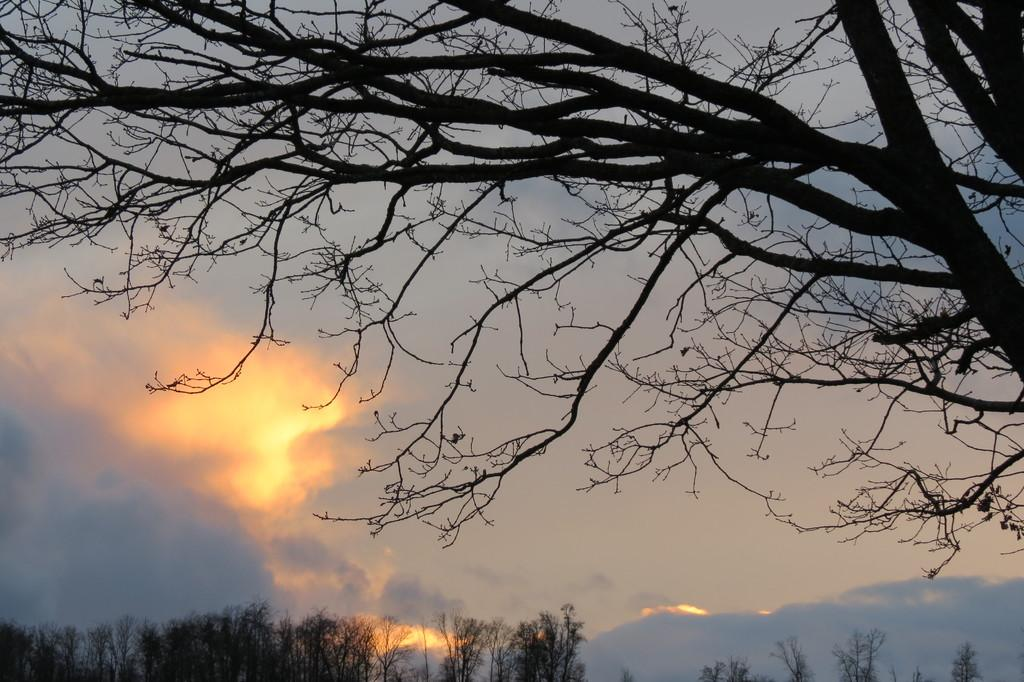What type of vegetation can be seen on the right side of the image? There is a tree on the right side of the image. What is visible at the bottom of the image? There are trees at the bottom of the image. What part of the natural environment is visible in the image? The sky is visible in the image. What can be seen in the sky? Clouds are present in the sky. What type of beef can be seen hanging from the tree in the image? There is no beef present in the image; it features a tree and clouds in the sky. How many cars are visible in the image? There are no cars visible in the image. 